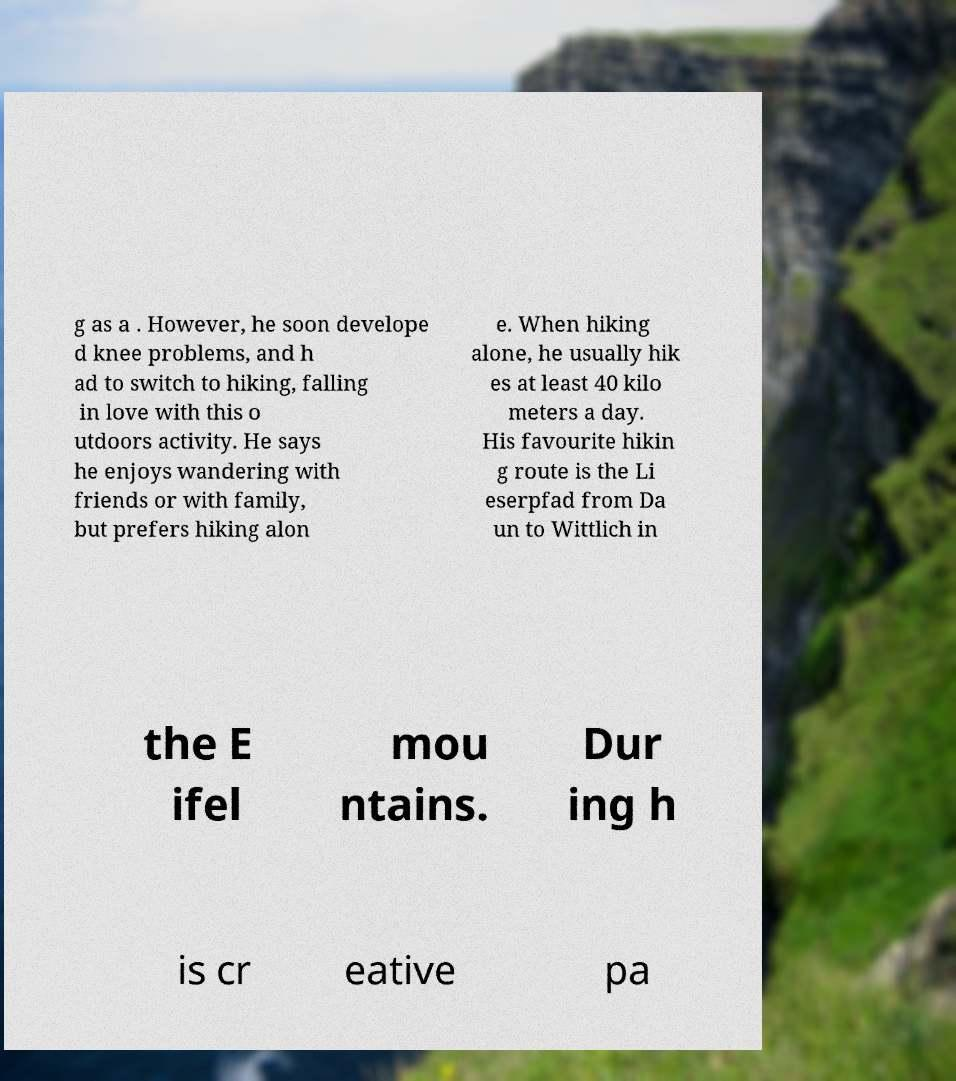There's text embedded in this image that I need extracted. Can you transcribe it verbatim? g as a . However, he soon develope d knee problems, and h ad to switch to hiking, falling in love with this o utdoors activity. He says he enjoys wandering with friends or with family, but prefers hiking alon e. When hiking alone, he usually hik es at least 40 kilo meters a day. His favourite hikin g route is the Li eserpfad from Da un to Wittlich in the E ifel mou ntains. Dur ing h is cr eative pa 